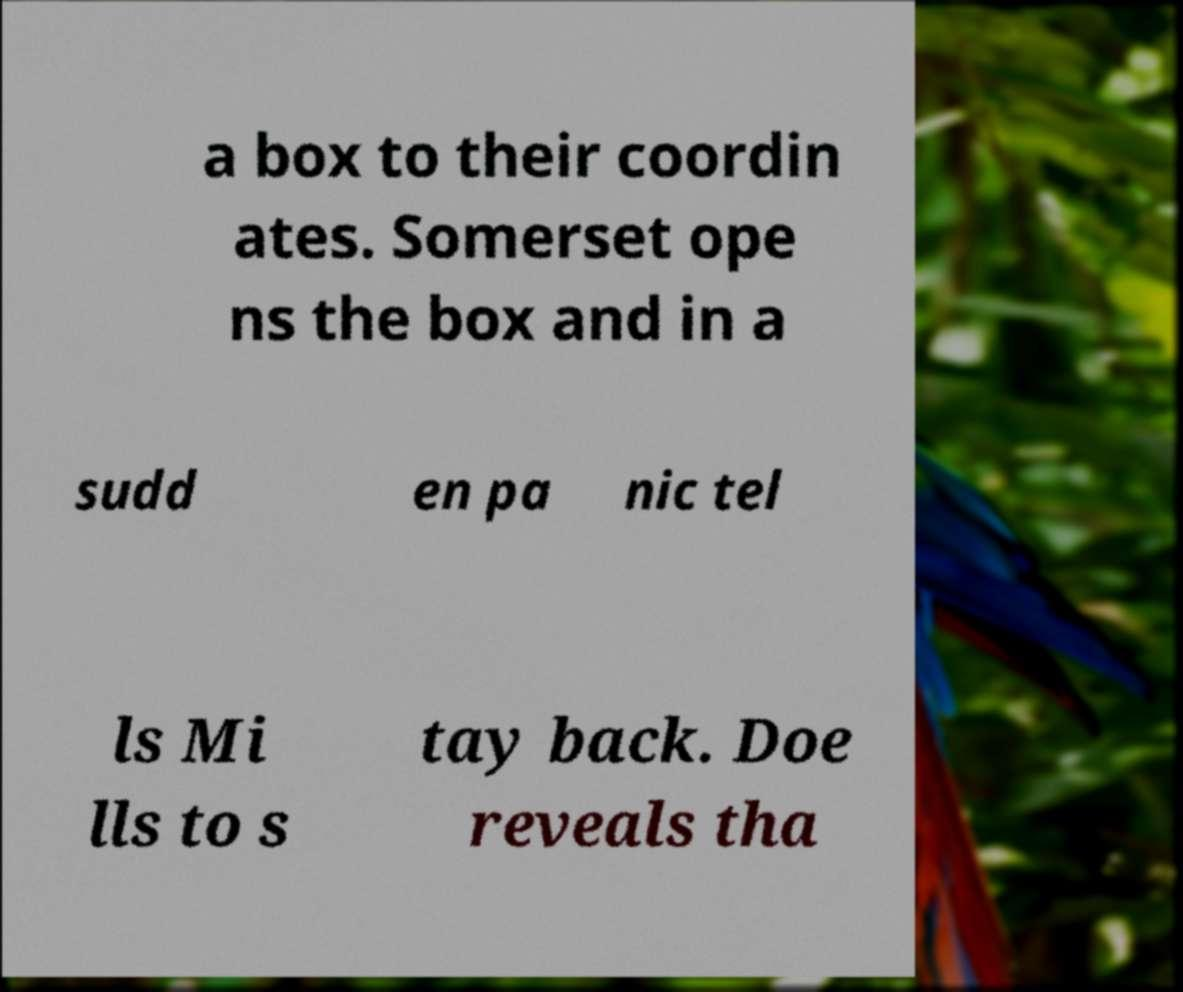I need the written content from this picture converted into text. Can you do that? a box to their coordin ates. Somerset ope ns the box and in a sudd en pa nic tel ls Mi lls to s tay back. Doe reveals tha 